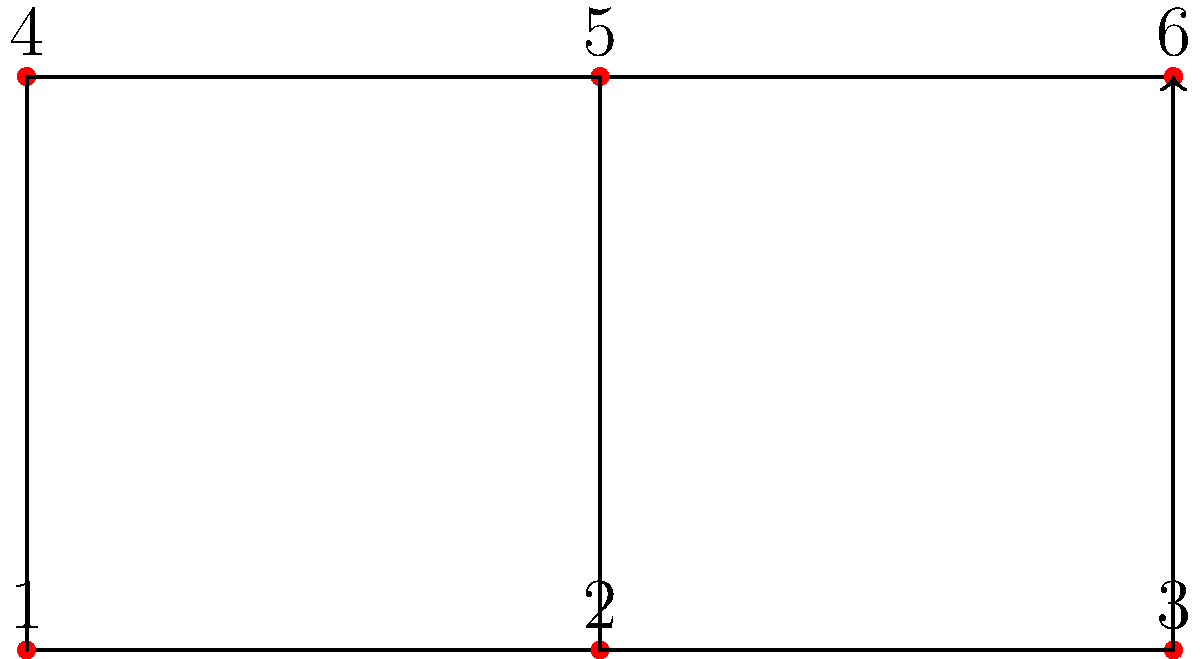In a sepak takraw court, a player needs to cover all six positions in the most efficient manner. The diagram shows the court layout with numbered positions. What is the optimal path for the player to cover all positions, starting from position 1, if they can only move to adjacent positions (including diagonally) and must end at a different position than where they started? To find the optimal path, we need to consider the following steps:

1. Start at position 1 (0,0).
2. The player can move to adjacent positions, including diagonally.
3. We need to cover all 6 positions with the shortest path.
4. The path should end at a different position than the starting point.

Let's analyze the possible moves:

1. From position 1, the optimal move is to position 4 (0,1), as it covers the most distance.
2. From position 4, moving to position 5 (1,1) is optimal as it's adjacent and covers a new position.
3. From position 5, the best move is to position 2 (1,0), covering another new position.
4. From position 2, moving to position 3 (2,0) is the only option to cover a new position.
5. Finally, from position 3, moving to position 6 (2,1) covers the last position and ends at a different point than the start.

The optimal path can be represented as a sequence of position numbers: 1 → 4 → 5 → 2 → 3 → 6

This path ensures that:
- All positions are covered
- Only adjacent moves are made
- The path ends at a different position than the start
- The total distance traveled is minimized
Answer: 1 → 4 → 5 → 2 → 3 → 6 